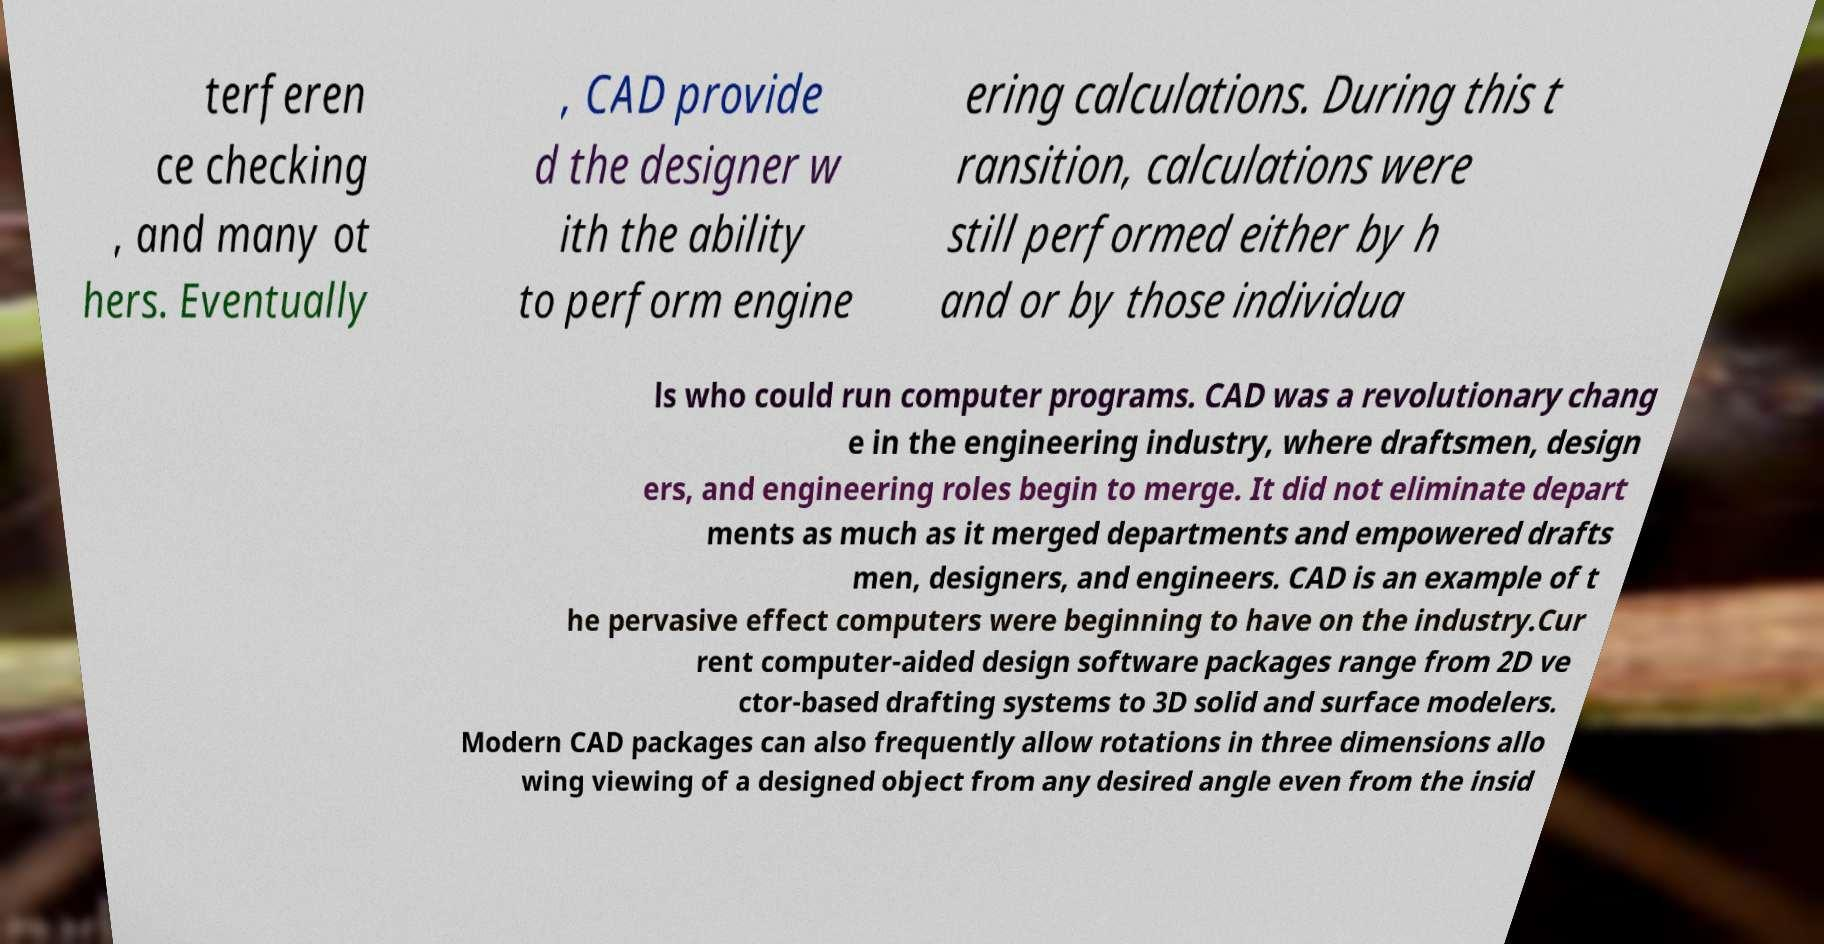Could you assist in decoding the text presented in this image and type it out clearly? terferen ce checking , and many ot hers. Eventually , CAD provide d the designer w ith the ability to perform engine ering calculations. During this t ransition, calculations were still performed either by h and or by those individua ls who could run computer programs. CAD was a revolutionary chang e in the engineering industry, where draftsmen, design ers, and engineering roles begin to merge. It did not eliminate depart ments as much as it merged departments and empowered drafts men, designers, and engineers. CAD is an example of t he pervasive effect computers were beginning to have on the industry.Cur rent computer-aided design software packages range from 2D ve ctor-based drafting systems to 3D solid and surface modelers. Modern CAD packages can also frequently allow rotations in three dimensions allo wing viewing of a designed object from any desired angle even from the insid 